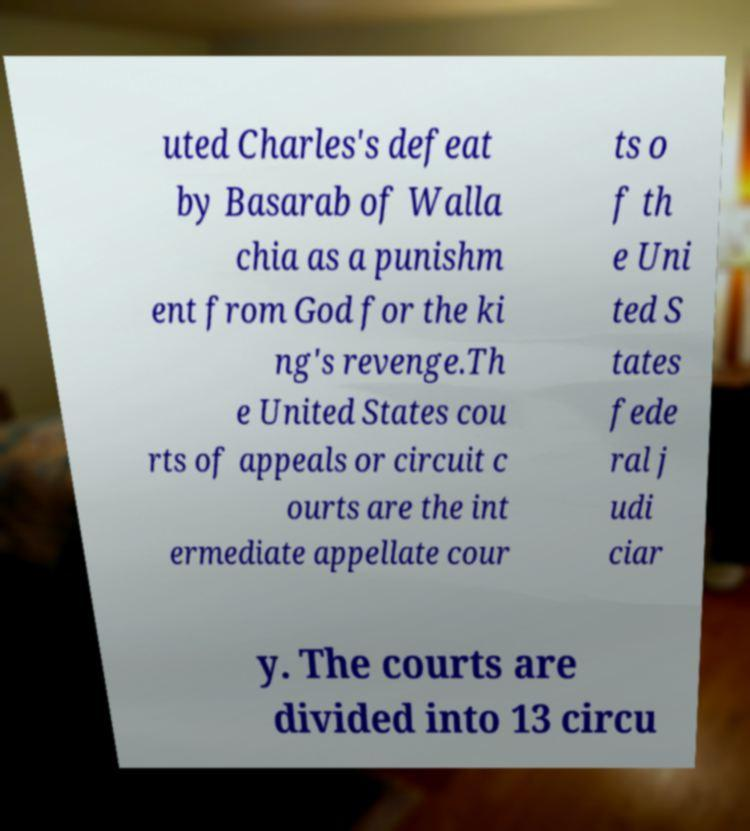Could you extract and type out the text from this image? uted Charles's defeat by Basarab of Walla chia as a punishm ent from God for the ki ng's revenge.Th e United States cou rts of appeals or circuit c ourts are the int ermediate appellate cour ts o f th e Uni ted S tates fede ral j udi ciar y. The courts are divided into 13 circu 